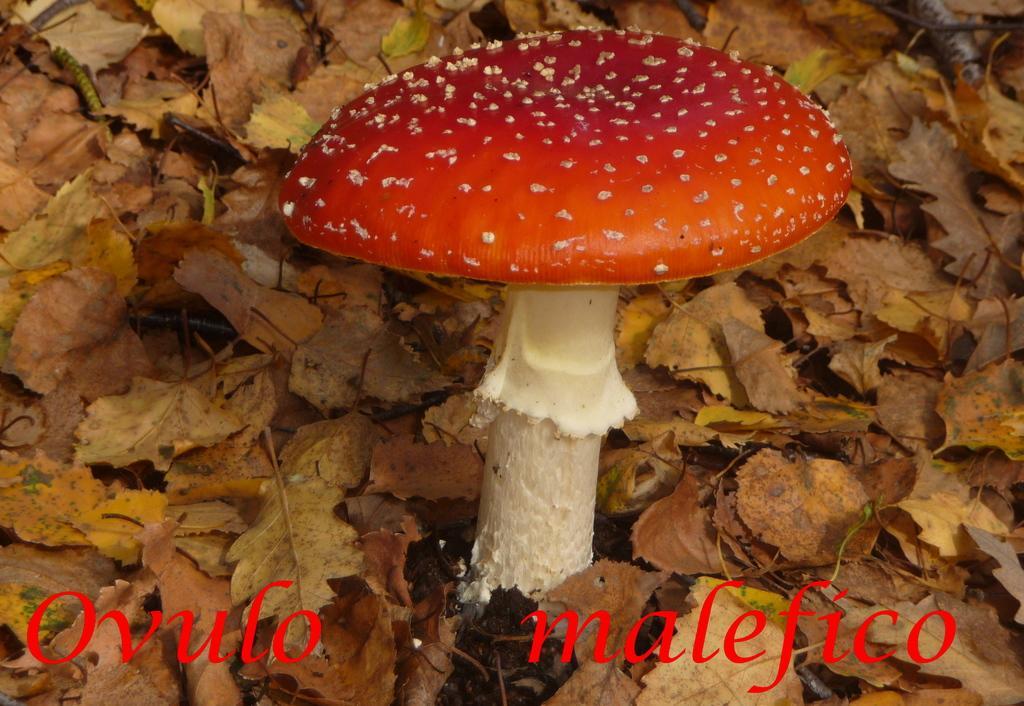Describe this image in one or two sentences. In this image I can see a mushroom which is in white and red color. It is on the ground. To the side I can see many dried leaves. 